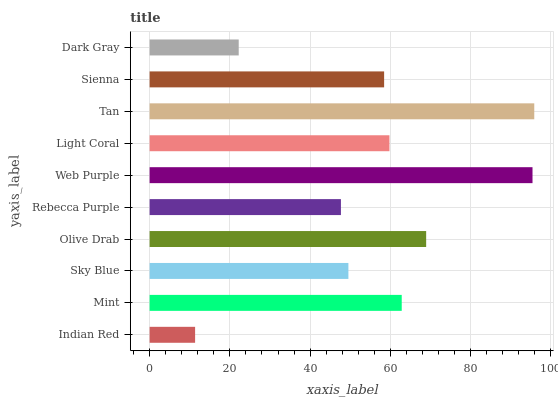Is Indian Red the minimum?
Answer yes or no. Yes. Is Tan the maximum?
Answer yes or no. Yes. Is Mint the minimum?
Answer yes or no. No. Is Mint the maximum?
Answer yes or no. No. Is Mint greater than Indian Red?
Answer yes or no. Yes. Is Indian Red less than Mint?
Answer yes or no. Yes. Is Indian Red greater than Mint?
Answer yes or no. No. Is Mint less than Indian Red?
Answer yes or no. No. Is Light Coral the high median?
Answer yes or no. Yes. Is Sienna the low median?
Answer yes or no. Yes. Is Web Purple the high median?
Answer yes or no. No. Is Tan the low median?
Answer yes or no. No. 